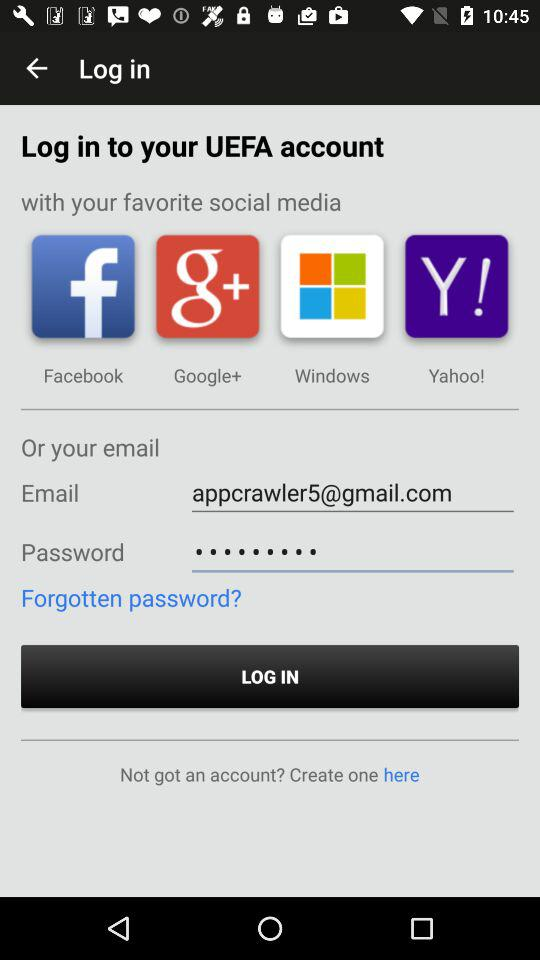What are the requirements to log in? The requirements to log in are email and password. 